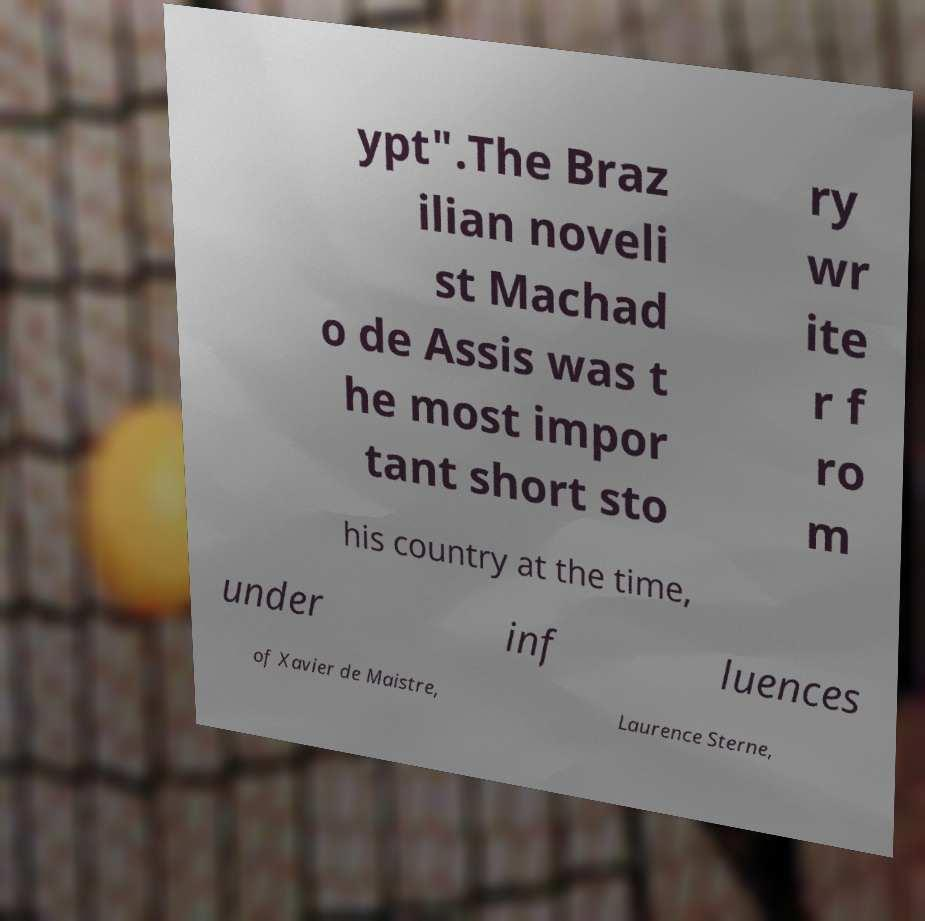Please read and relay the text visible in this image. What does it say? ypt".The Braz ilian noveli st Machad o de Assis was t he most impor tant short sto ry wr ite r f ro m his country at the time, under inf luences of Xavier de Maistre, Laurence Sterne, 